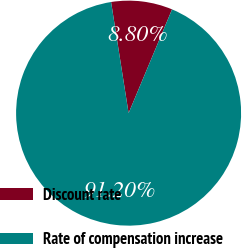Convert chart to OTSL. <chart><loc_0><loc_0><loc_500><loc_500><pie_chart><fcel>Discount rate<fcel>Rate of compensation increase<nl><fcel>8.8%<fcel>91.2%<nl></chart> 